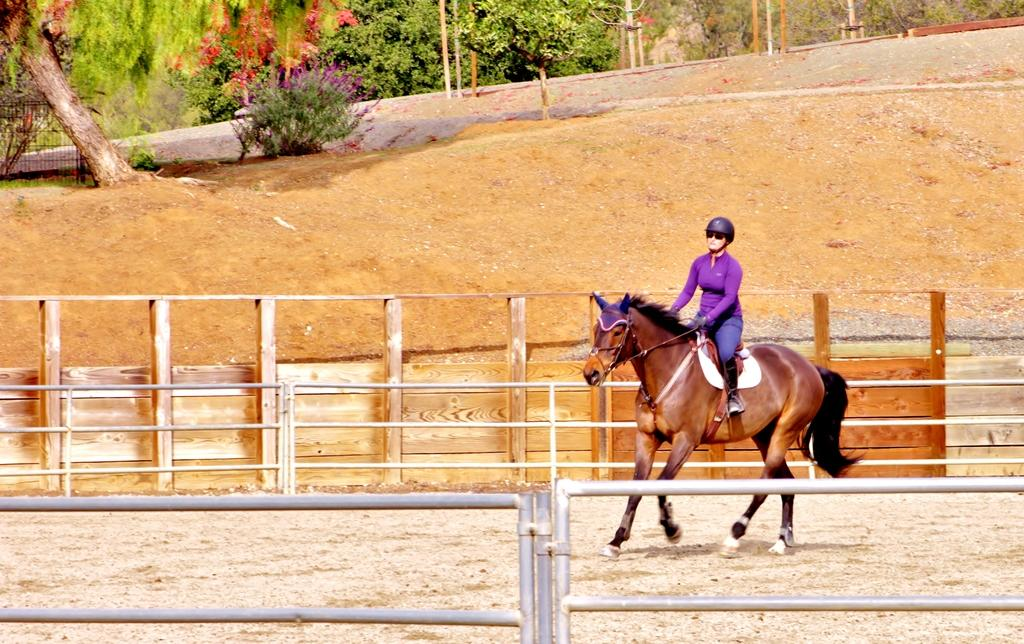What type of vegetation can be seen in the image? There are trees and a plant in the image. What is the woman in the image doing? The woman is riding a horse in the image. What type of harmony is being played by the trees in the image? There is no harmony being played by the trees in the image, as trees do not produce music. 